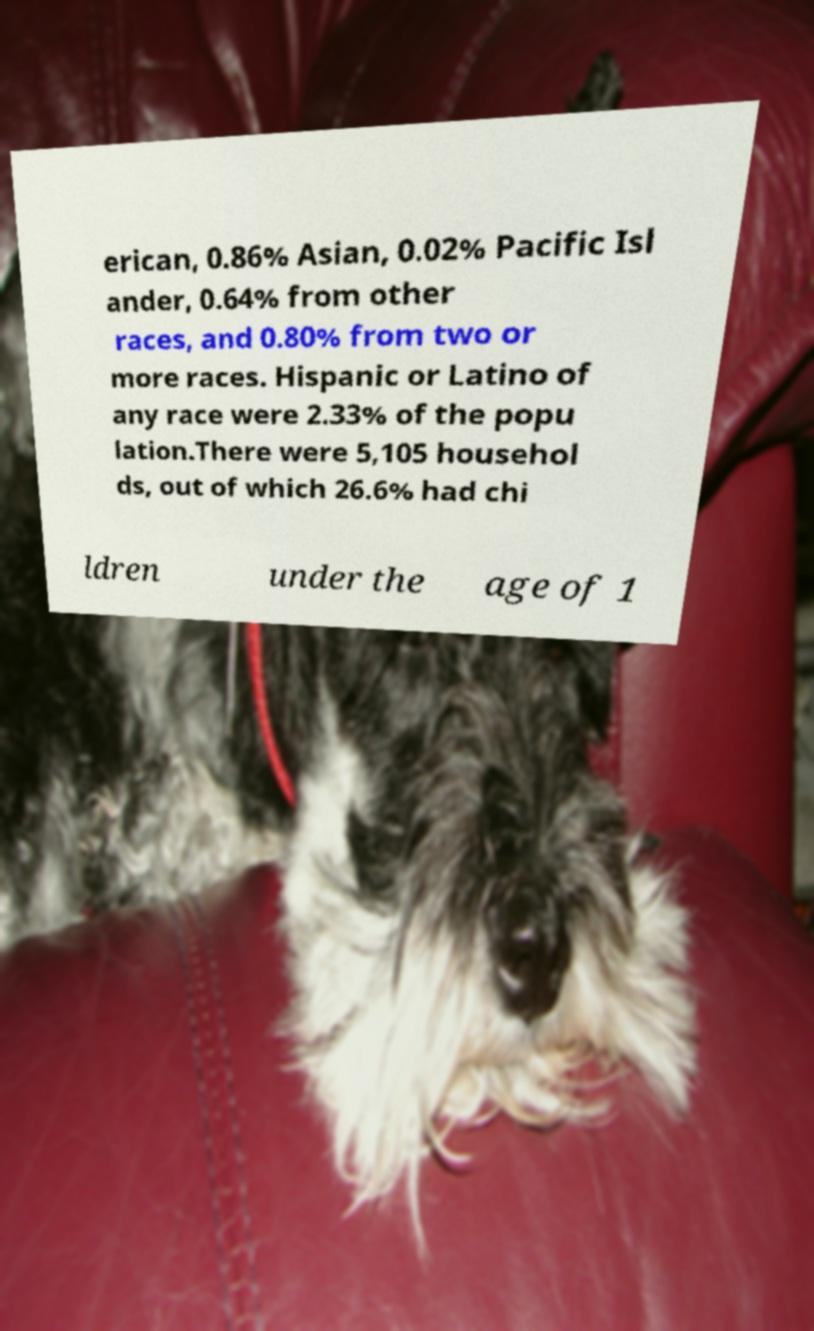For documentation purposes, I need the text within this image transcribed. Could you provide that? erican, 0.86% Asian, 0.02% Pacific Isl ander, 0.64% from other races, and 0.80% from two or more races. Hispanic or Latino of any race were 2.33% of the popu lation.There were 5,105 househol ds, out of which 26.6% had chi ldren under the age of 1 